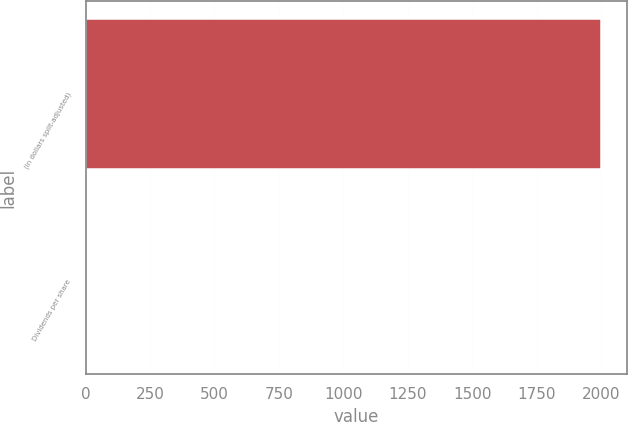Convert chart. <chart><loc_0><loc_0><loc_500><loc_500><bar_chart><fcel>(in dollars split-adjusted)<fcel>Dividends per share<nl><fcel>1999<fcel>0.57<nl></chart> 